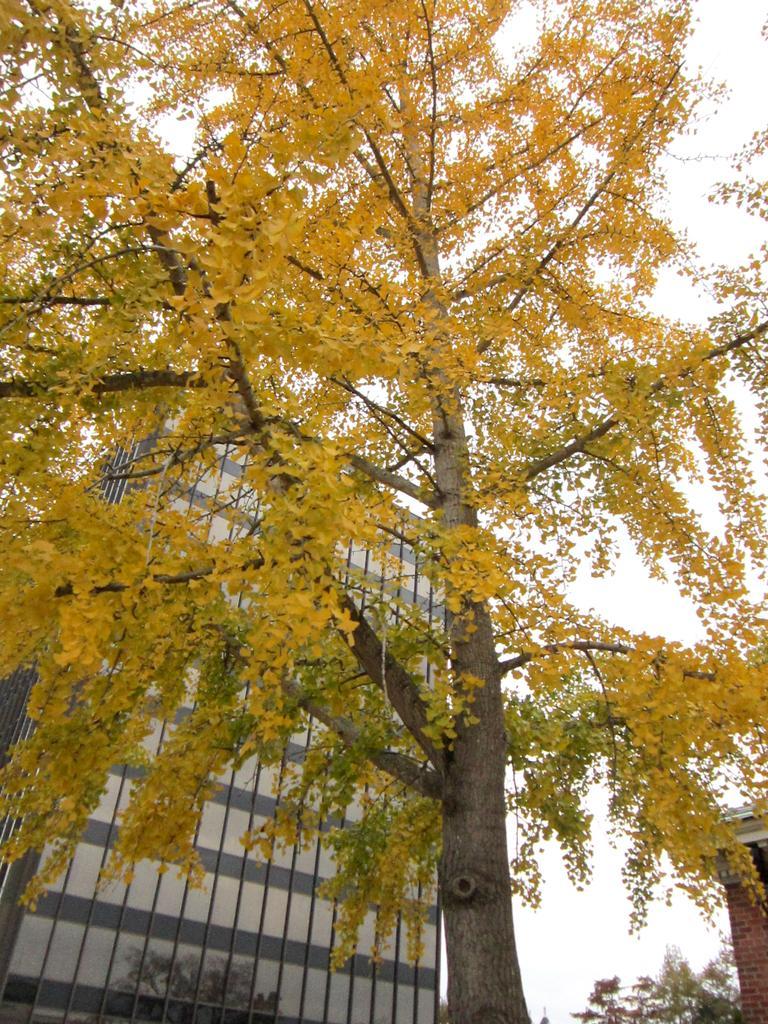Please provide a concise description of this image. We can see tree. In the background we can see building,tree and sky. 